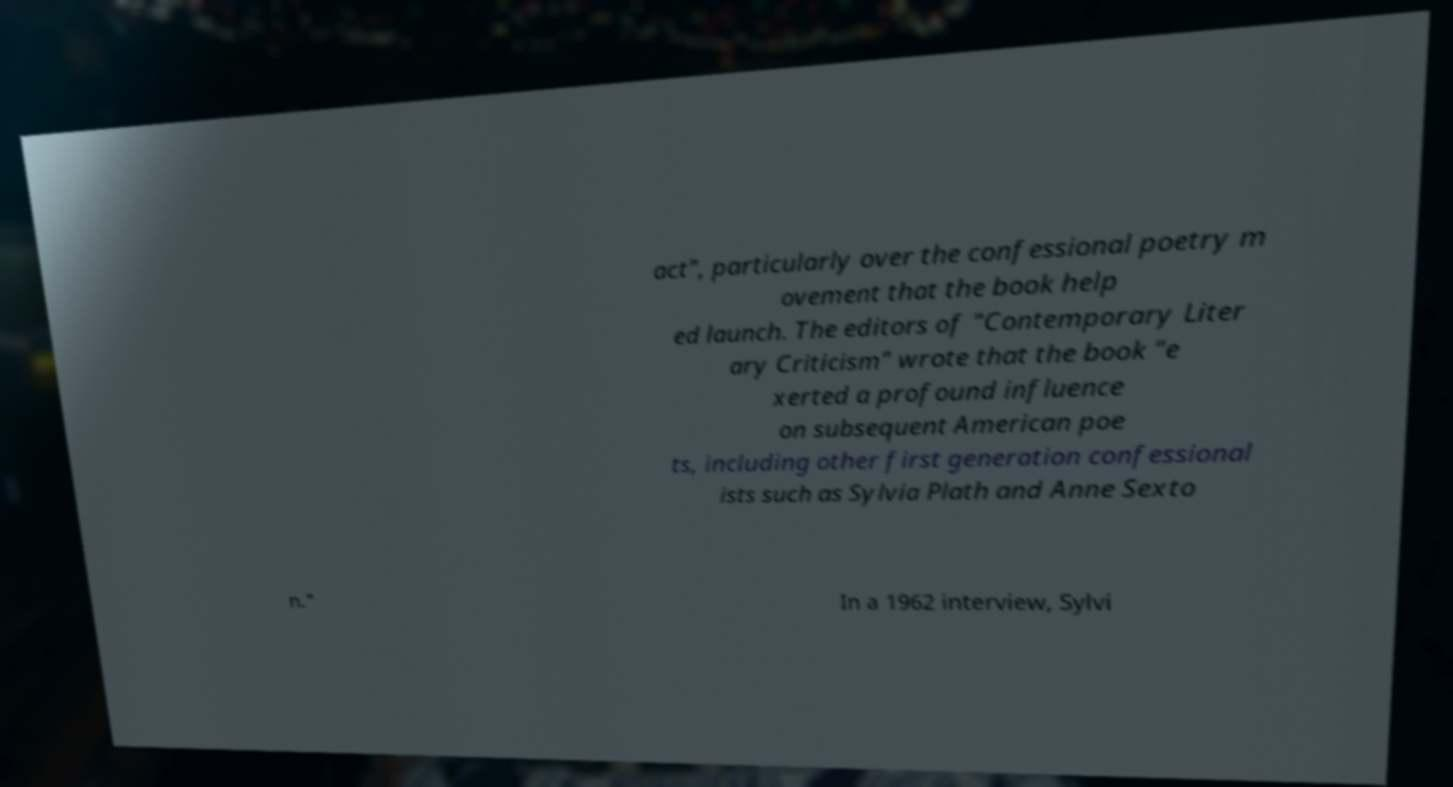Can you read and provide the text displayed in the image?This photo seems to have some interesting text. Can you extract and type it out for me? act", particularly over the confessional poetry m ovement that the book help ed launch. The editors of "Contemporary Liter ary Criticism" wrote that the book "e xerted a profound influence on subsequent American poe ts, including other first generation confessional ists such as Sylvia Plath and Anne Sexto n." In a 1962 interview, Sylvi 